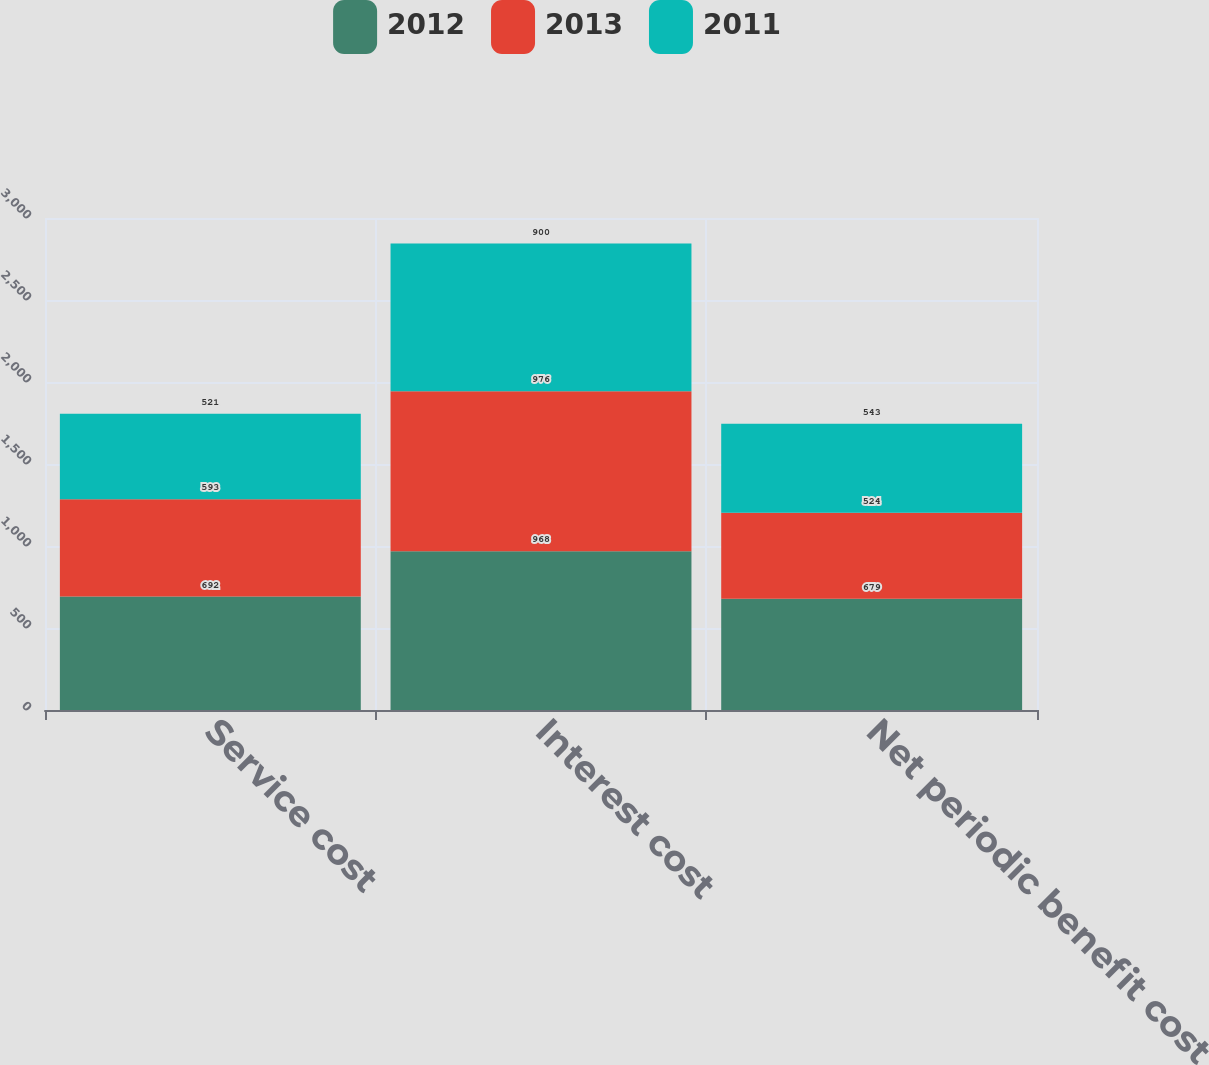<chart> <loc_0><loc_0><loc_500><loc_500><stacked_bar_chart><ecel><fcel>Service cost<fcel>Interest cost<fcel>Net periodic benefit cost<nl><fcel>2012<fcel>692<fcel>968<fcel>679<nl><fcel>2013<fcel>593<fcel>976<fcel>524<nl><fcel>2011<fcel>521<fcel>900<fcel>543<nl></chart> 